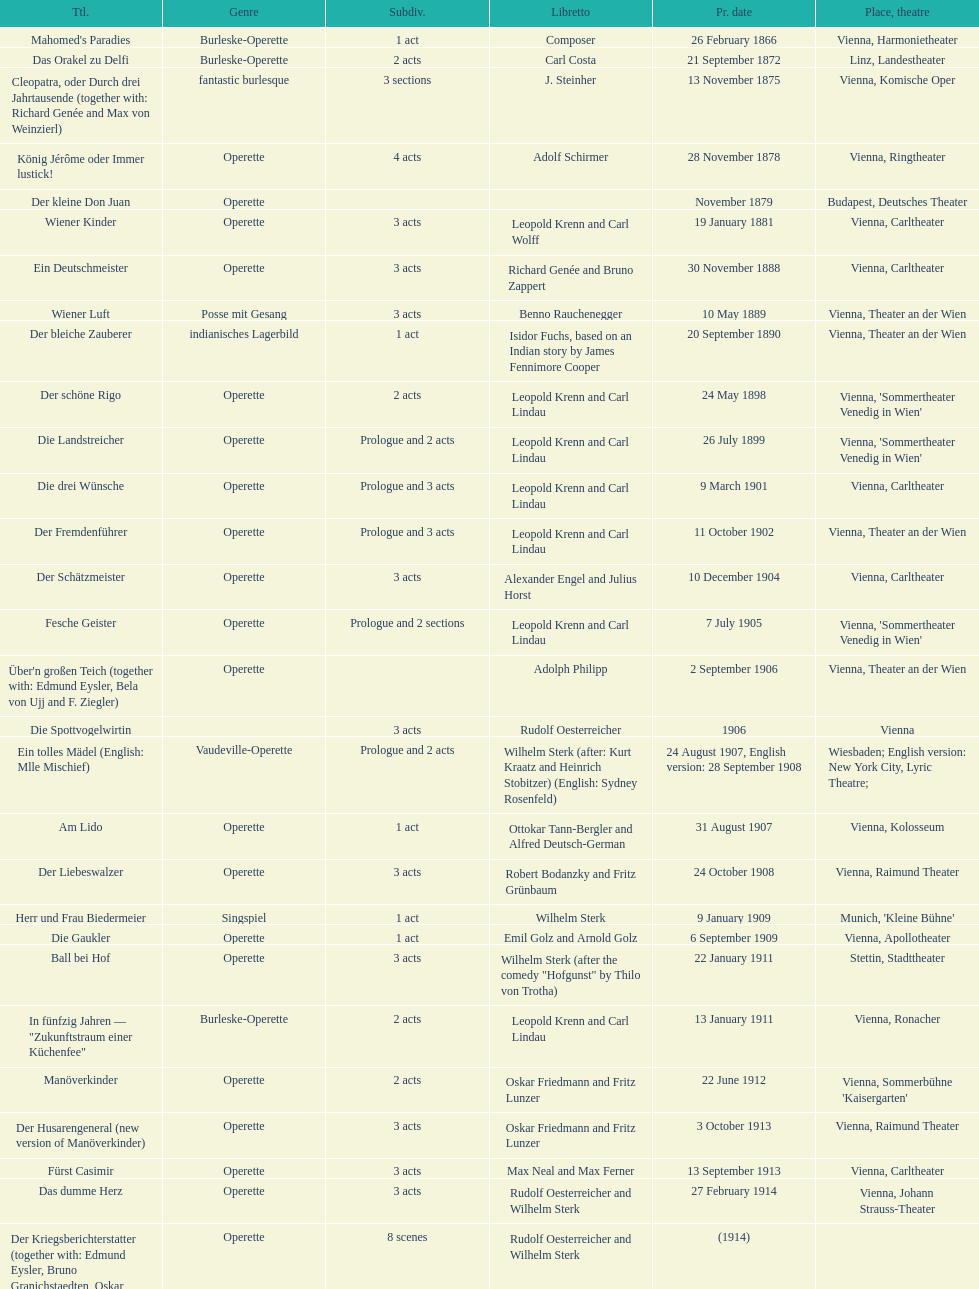Which genre is featured the most in this chart? Operette. 